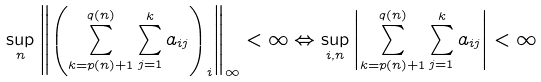<formula> <loc_0><loc_0><loc_500><loc_500>\sup _ { n } \left \| \left ( \sum _ { k = p ( n ) + 1 } ^ { q ( n ) } \sum _ { j = 1 } ^ { k } a _ { i j } \right ) _ { i } \right \| _ { \infty } < \infty \Leftrightarrow \sup _ { i , n } \left | \sum _ { k = p ( n ) + 1 } ^ { q ( n ) } \sum _ { j = 1 } ^ { k } a _ { i j } \right | < \infty</formula> 